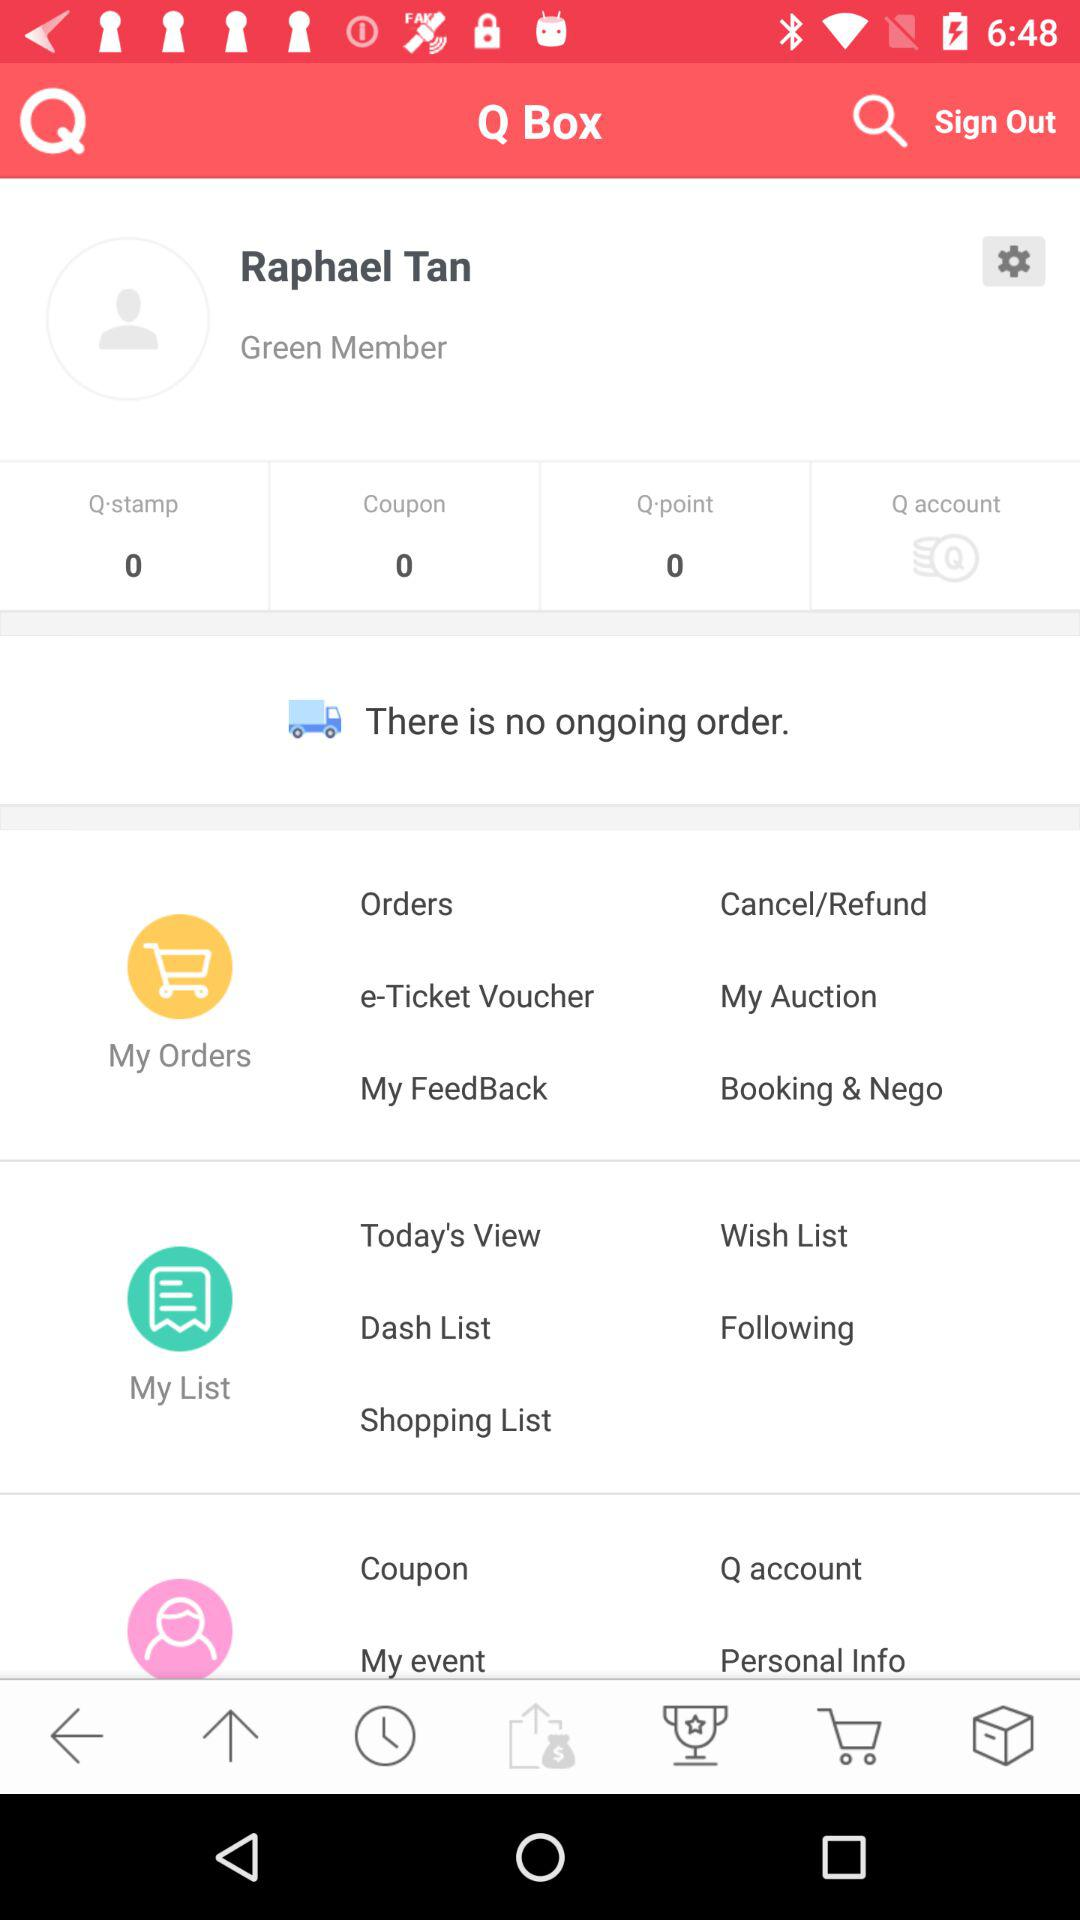How many Q accounts are there?
When the provided information is insufficient, respond with <no answer>. <no answer> 